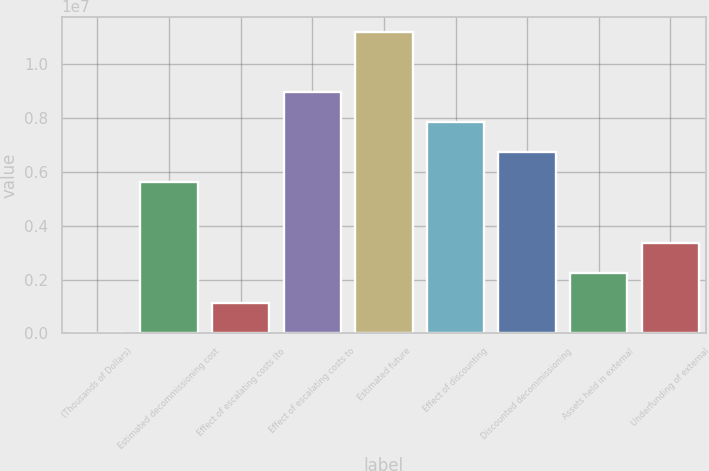Convert chart to OTSL. <chart><loc_0><loc_0><loc_500><loc_500><bar_chart><fcel>(Thousands of Dollars)<fcel>Estimated decommissioning cost<fcel>Effect of escalating costs (to<fcel>Effect of escalating costs to<fcel>Estimated future<fcel>Effect of discounting<fcel>Discounted decommissioning<fcel>Assets held in external<fcel>Underfunding of external<nl><fcel>2015<fcel>5.60375e+06<fcel>1.12236e+06<fcel>8.9648e+06<fcel>1.12055e+07<fcel>7.84445e+06<fcel>6.7241e+06<fcel>2.24271e+06<fcel>3.36306e+06<nl></chart> 